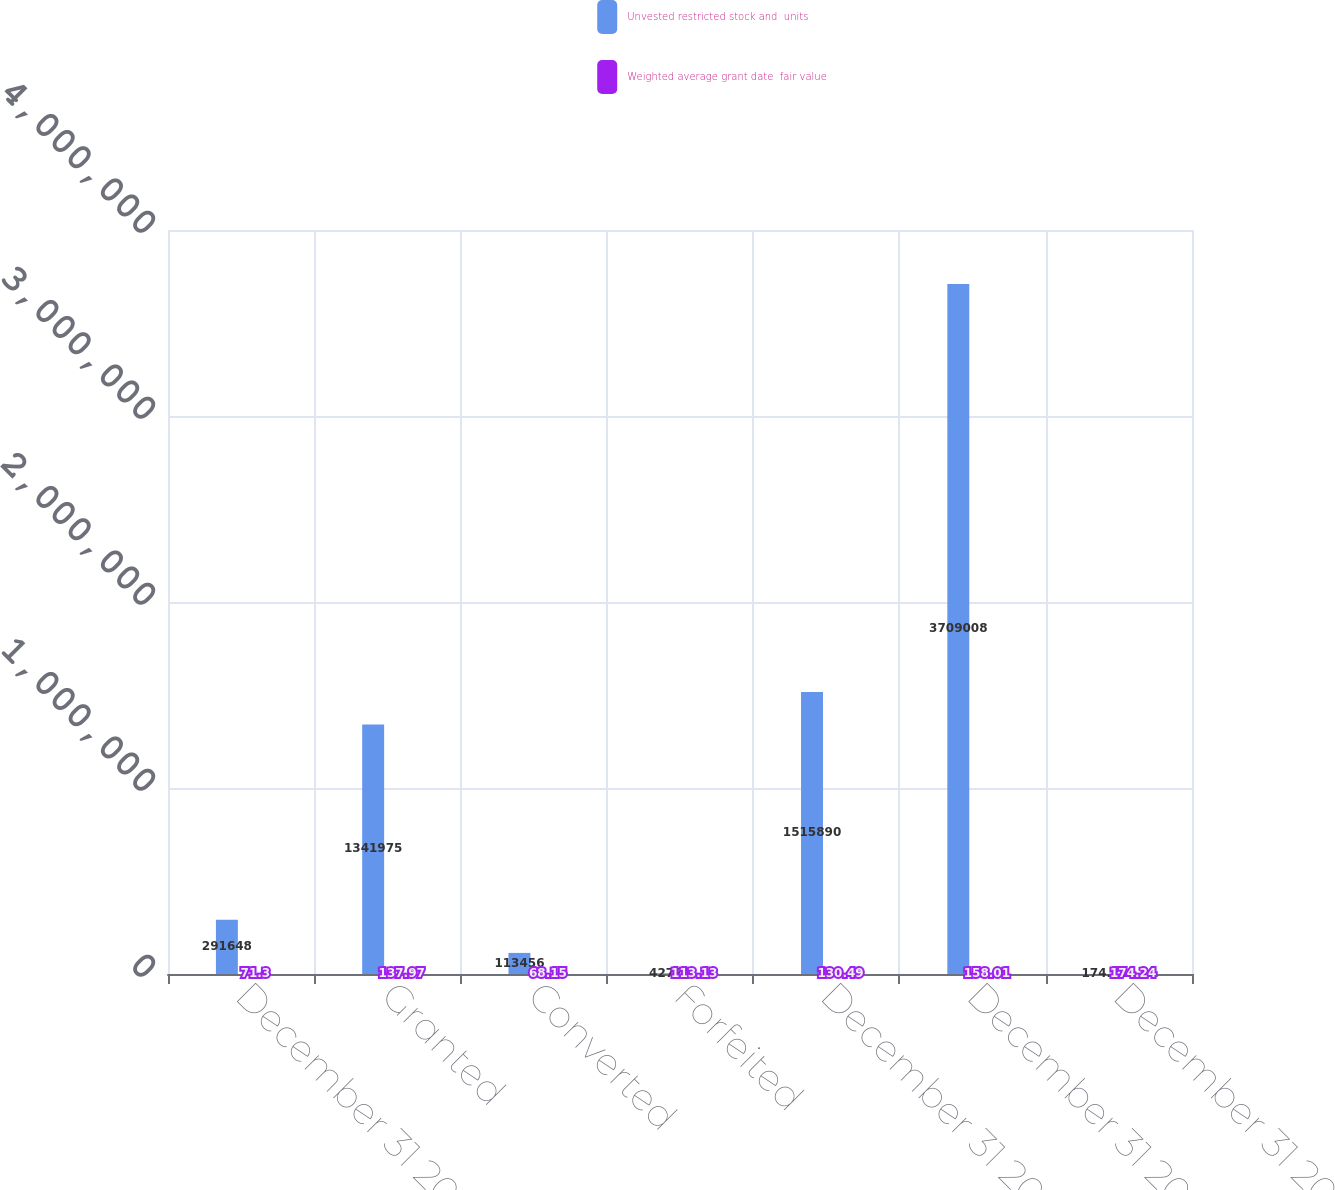Convert chart to OTSL. <chart><loc_0><loc_0><loc_500><loc_500><stacked_bar_chart><ecel><fcel>December 31 2005<fcel>Granted<fcel>Converted<fcel>Forfeited<fcel>December 31 2006<fcel>December 31 2007<fcel>December 31 2008 (1)<nl><fcel>Unvested restricted stock and  units<fcel>291648<fcel>1.34198e+06<fcel>113456<fcel>4277<fcel>1.51589e+06<fcel>3.70901e+06<fcel>174.24<nl><fcel>Weighted average grant date  fair value<fcel>71.3<fcel>137.97<fcel>68.15<fcel>113.13<fcel>130.49<fcel>158.01<fcel>174.24<nl></chart> 